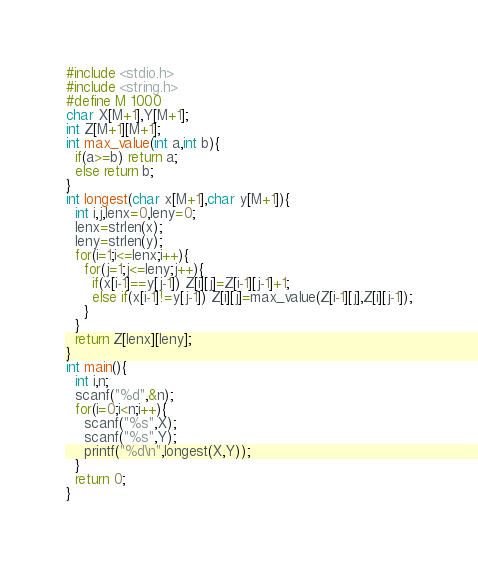Convert code to text. <code><loc_0><loc_0><loc_500><loc_500><_C_>#include <stdio.h>
#include <string.h>
#define M 1000
char X[M+1],Y[M+1];
int Z[M+1][M+1];
int max_value(int a,int b){
  if(a>=b) return a;
  else return b;
}
int longest(char x[M+1],char y[M+1]){
  int i,j,lenx=0,leny=0;
  lenx=strlen(x);
  leny=strlen(y);
  for(i=1;i<=lenx;i++){
    for(j=1;j<=leny;j++){
      if(x[i-1]==y[j-1]) Z[i][j]=Z[i-1][j-1]+1;
      else if(x[i-1]!=y[j-1]) Z[i][j]=max_value(Z[i-1][j],Z[i][j-1]);
    }
  }
  return Z[lenx][leny];
}
int main(){
  int i,n;
  scanf("%d",&n);
  for(i=0;i<n;i++){
    scanf("%s",X);
    scanf("%s",Y);
    printf("%d\n",longest(X,Y));
  }
  return 0;
}</code> 